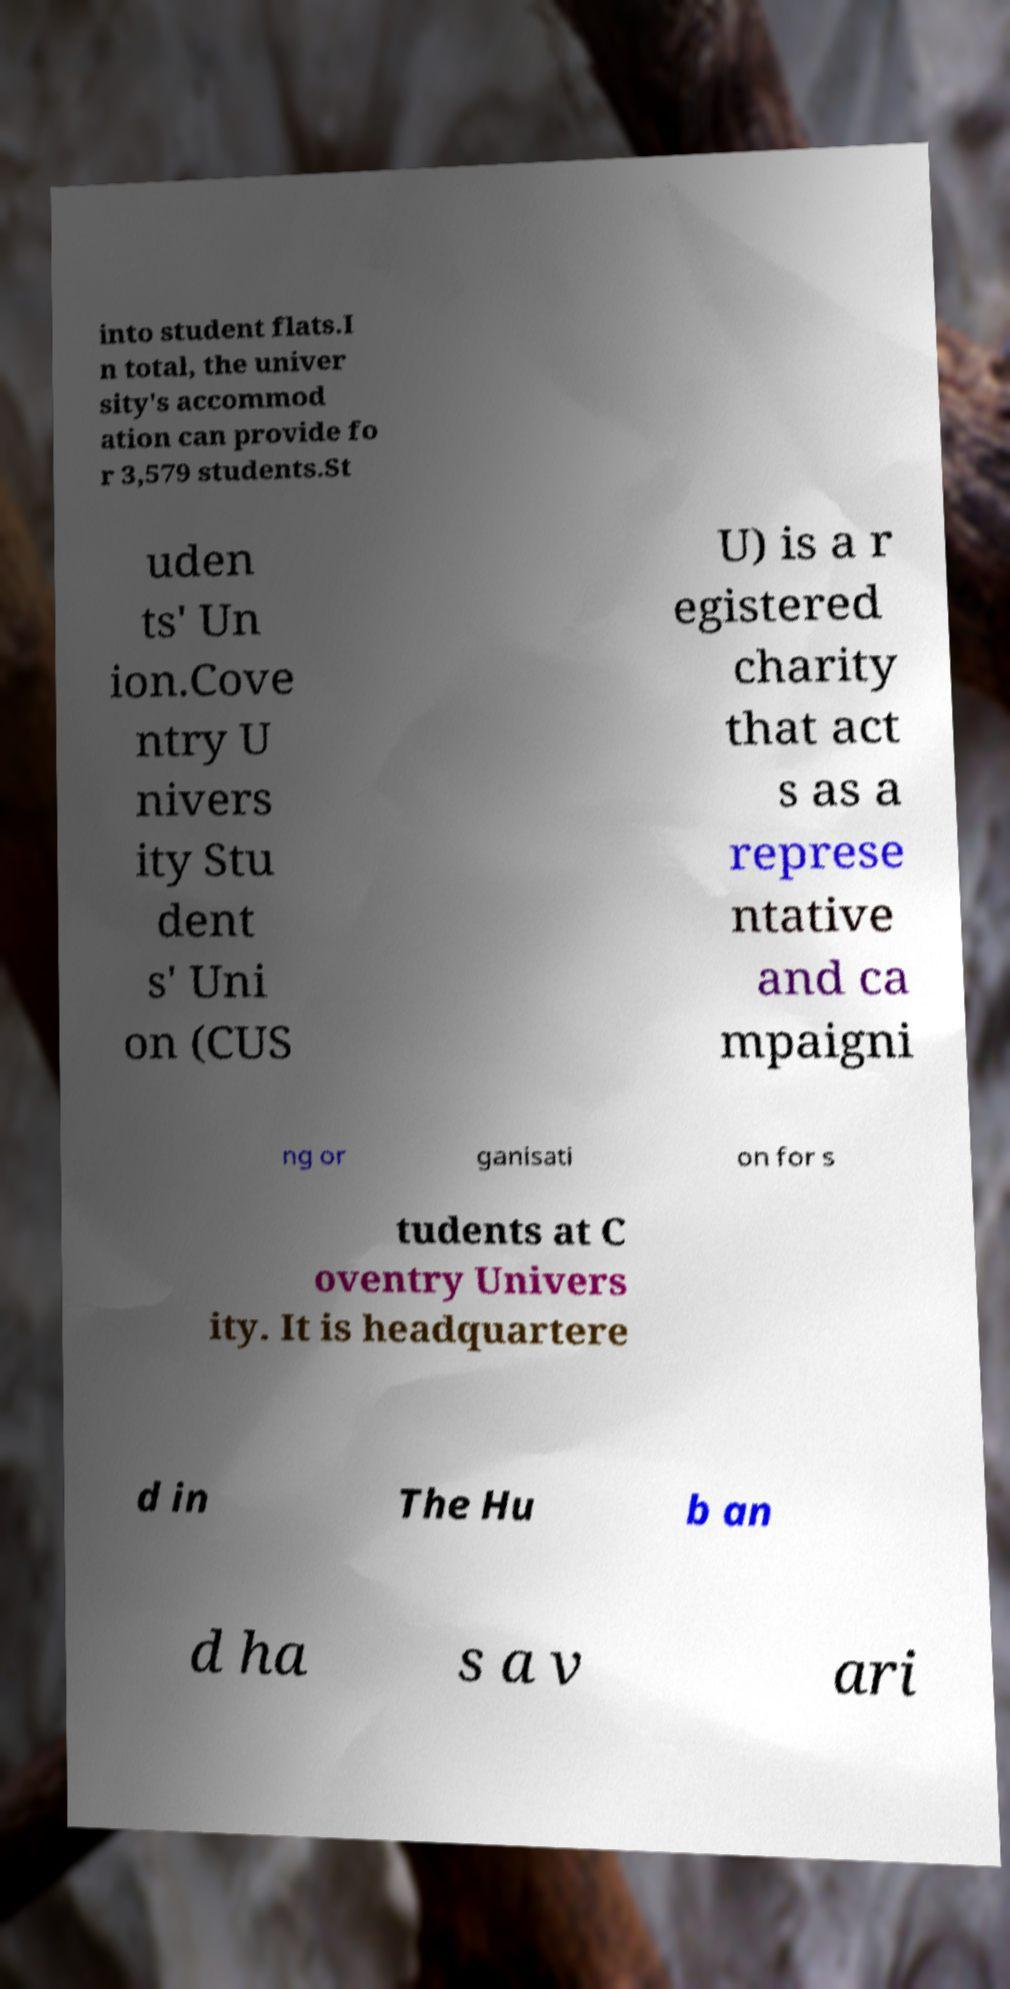Can you read and provide the text displayed in the image?This photo seems to have some interesting text. Can you extract and type it out for me? into student flats.I n total, the univer sity's accommod ation can provide fo r 3,579 students.St uden ts' Un ion.Cove ntry U nivers ity Stu dent s' Uni on (CUS U) is a r egistered charity that act s as a represe ntative and ca mpaigni ng or ganisati on for s tudents at C oventry Univers ity. It is headquartere d in The Hu b an d ha s a v ari 